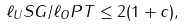<formula> <loc_0><loc_0><loc_500><loc_500>\ell _ { U } S G / \ell _ { O } P T \leq 2 ( 1 + c ) ,</formula> 